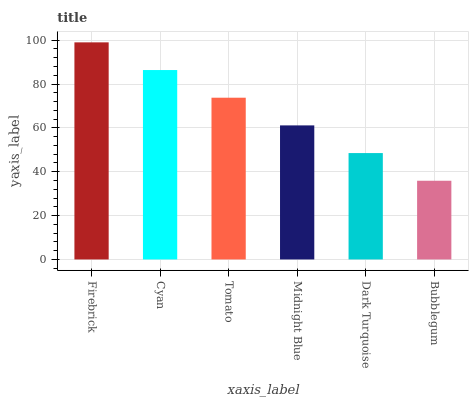Is Bubblegum the minimum?
Answer yes or no. Yes. Is Firebrick the maximum?
Answer yes or no. Yes. Is Cyan the minimum?
Answer yes or no. No. Is Cyan the maximum?
Answer yes or no. No. Is Firebrick greater than Cyan?
Answer yes or no. Yes. Is Cyan less than Firebrick?
Answer yes or no. Yes. Is Cyan greater than Firebrick?
Answer yes or no. No. Is Firebrick less than Cyan?
Answer yes or no. No. Is Tomato the high median?
Answer yes or no. Yes. Is Midnight Blue the low median?
Answer yes or no. Yes. Is Dark Turquoise the high median?
Answer yes or no. No. Is Cyan the low median?
Answer yes or no. No. 